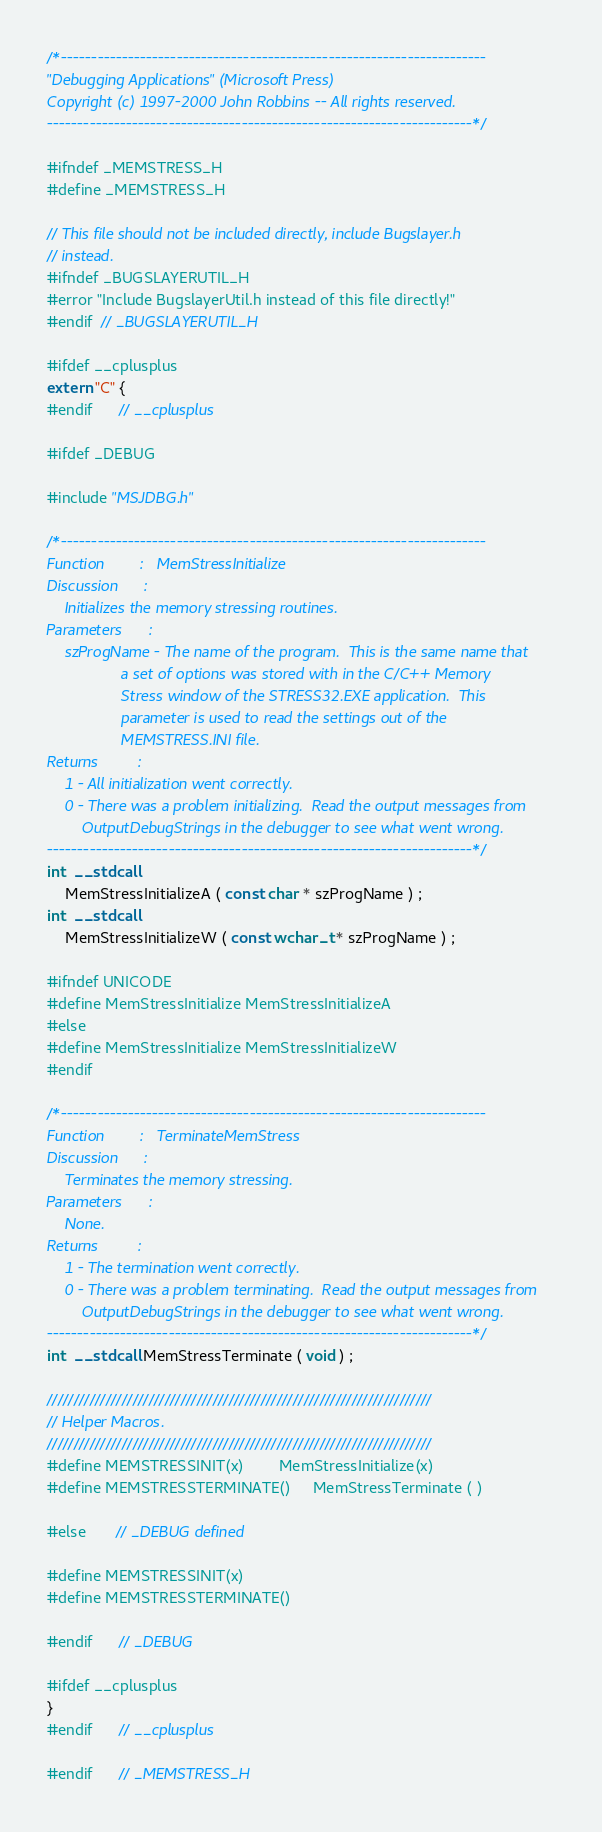Convert code to text. <code><loc_0><loc_0><loc_500><loc_500><_C_>/*----------------------------------------------------------------------
"Debugging Applications" (Microsoft Press)
Copyright (c) 1997-2000 John Robbins -- All rights reserved.
----------------------------------------------------------------------*/

#ifndef _MEMSTRESS_H
#define _MEMSTRESS_H

// This file should not be included directly, include Bugslayer.h
// instead.
#ifndef _BUGSLAYERUTIL_H
#error "Include BugslayerUtil.h instead of this file directly!"
#endif  // _BUGSLAYERUTIL_H

#ifdef __cplusplus
extern "C" {
#endif      // __cplusplus

#ifdef _DEBUG

#include "MSJDBG.h"

/*----------------------------------------------------------------------
Function        :   MemStressInitialize
Discussion      :
    Initializes the memory stressing routines.
Parameters      :
    szProgName - The name of the program.  This is the same name that
                 a set of options was stored with in the C/C++ Memory
                 Stress window of the STRESS32.EXE application.  This
                 parameter is used to read the settings out of the
                 MEMSTRESS.INI file.
Returns         :
    1 - All initialization went correctly.
    0 - There was a problem initializing.  Read the output messages from
        OutputDebugStrings in the debugger to see what went wrong.
----------------------------------------------------------------------*/
int  __stdcall
    MemStressInitializeA ( const char * szProgName ) ;
int  __stdcall
    MemStressInitializeW ( const wchar_t * szProgName ) ;

#ifndef UNICODE
#define MemStressInitialize MemStressInitializeA
#else
#define MemStressInitialize MemStressInitializeW
#endif

/*----------------------------------------------------------------------
Function        :   TerminateMemStress
Discussion      :
    Terminates the memory stressing.
Parameters      :
    None.
Returns         :
    1 - The termination went correctly.
    0 - There was a problem terminating.  Read the output messages from
        OutputDebugStrings in the debugger to see what went wrong.
----------------------------------------------------------------------*/
int  __stdcall MemStressTerminate ( void ) ;

////////////////////////////////////////////////////////////////////////
// Helper Macros.
////////////////////////////////////////////////////////////////////////
#define MEMSTRESSINIT(x)        MemStressInitialize(x)
#define MEMSTRESSTERMINATE()     MemStressTerminate ( )

#else       // _DEBUG defined

#define MEMSTRESSINIT(x)
#define MEMSTRESSTERMINATE()

#endif      // _DEBUG

#ifdef __cplusplus
}
#endif      // __cplusplus

#endif      // _MEMSTRESS_H


</code> 